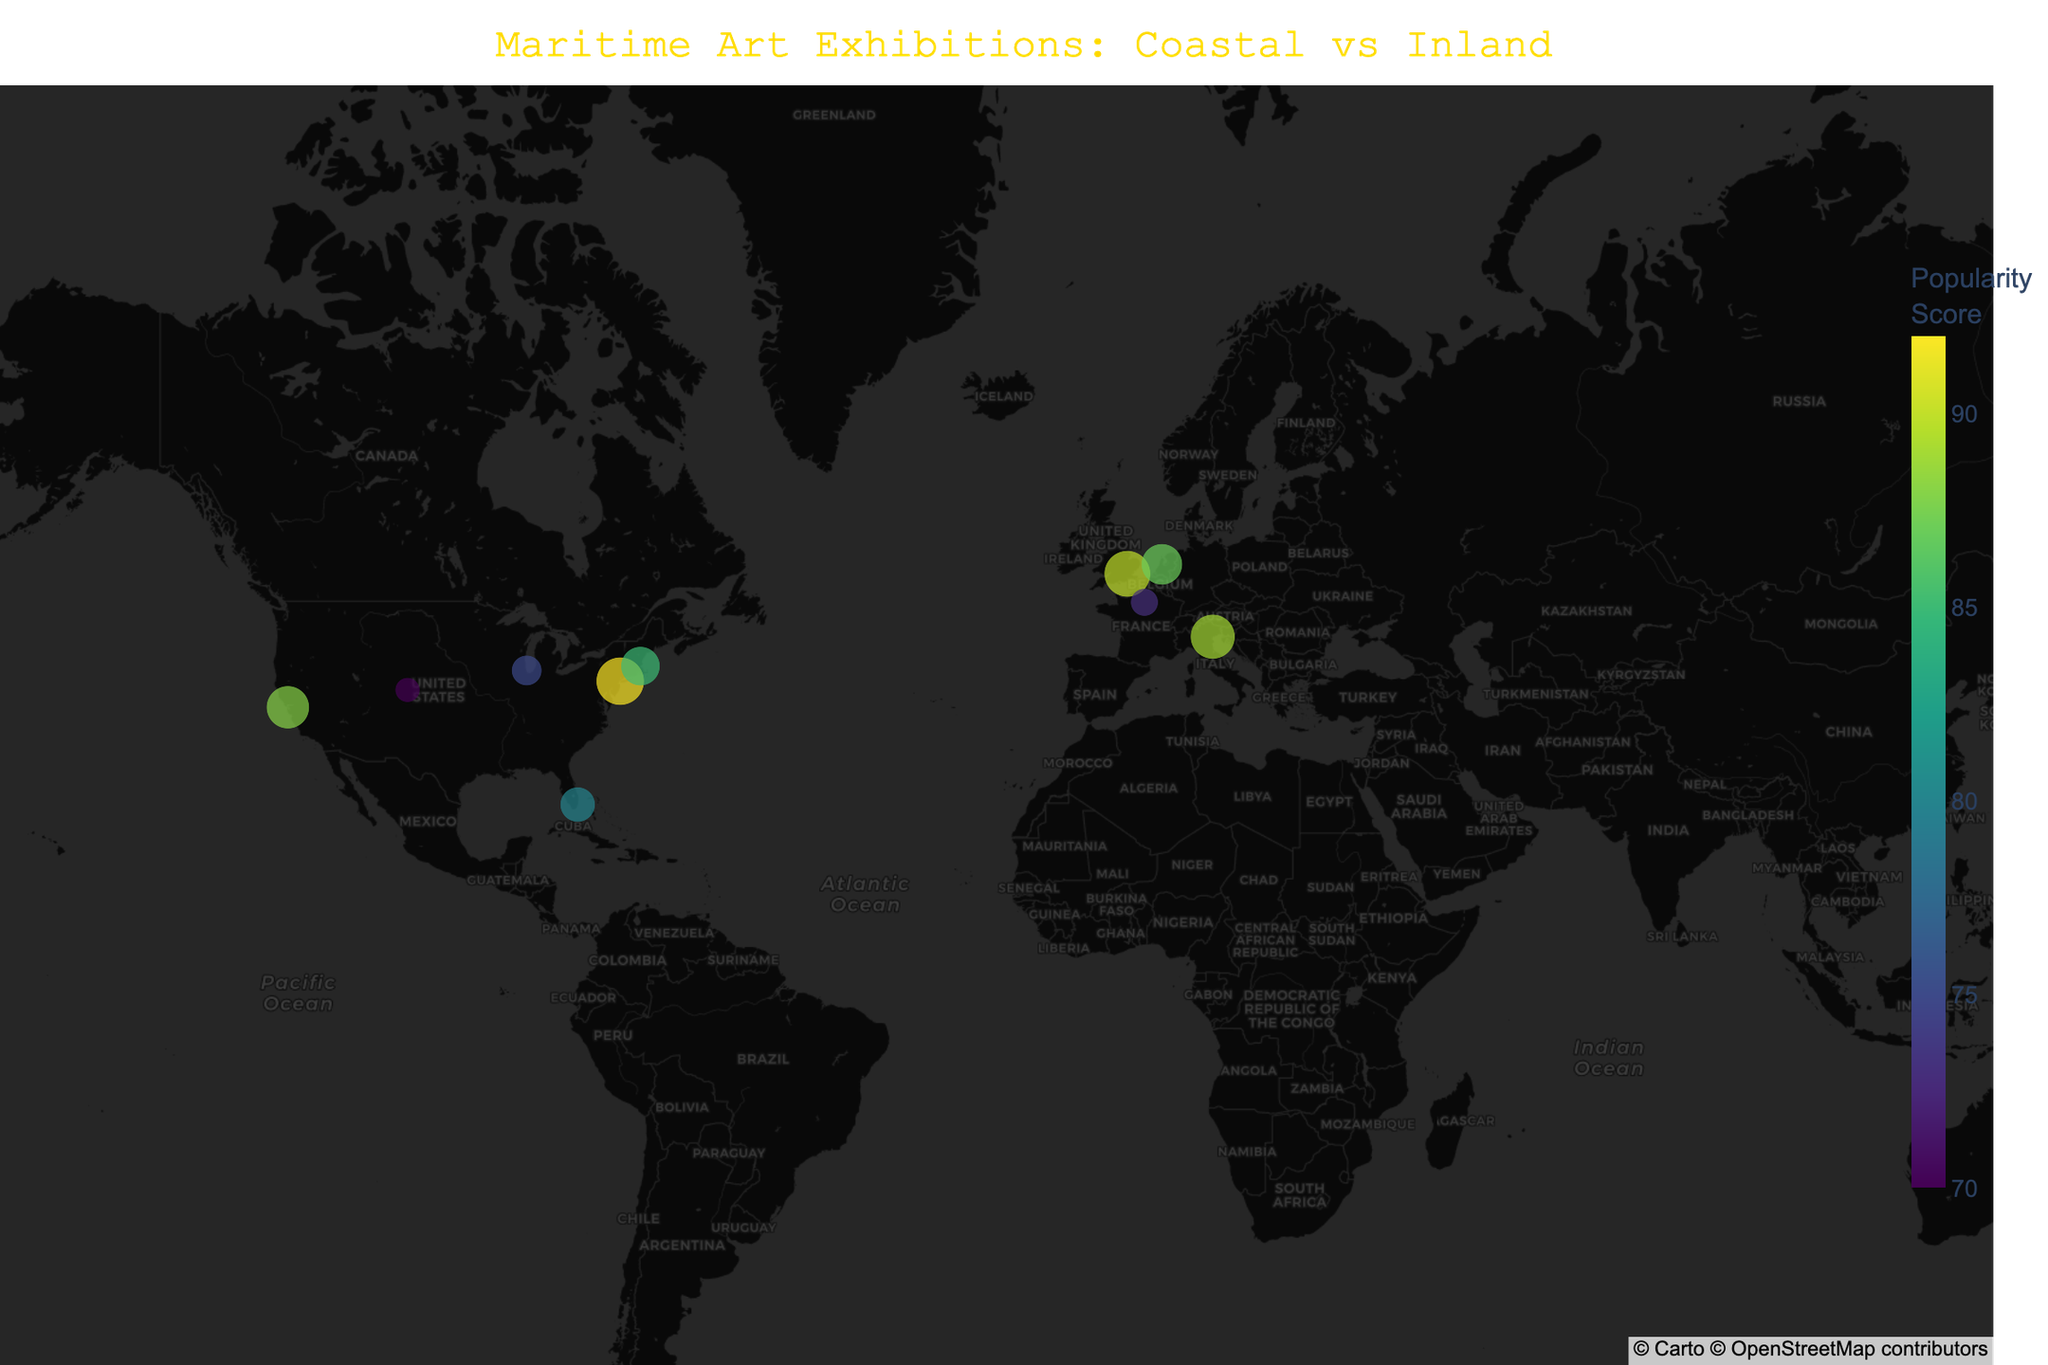How many coastal cities have exhibitions listed? To identify coastal cities, we need to consider those near water bodies like New York City, San Francisco, Boston, Miami, San Francisco, and Venice. Counting these, we get six.
Answer: 6 Which city has the highest popularity score? By examining the color gradient and the hover information in the figure, London and New York City both show high popularity scores. Checking the detailed scores, New York City has the highest at 92.
Answer: New York City Compare the total exhibition counts of coastal cities versus inland cities. Sum the "Exhibition Count" for coastal cities (NYC, SF, Boston, Miami, Venice): 15+12+10+8+13 = 58. For inland cities (Chicago, Denver, Tokyo, Paris): 6+4+7+5 = 22.
Answer: Coastal: 58, Inland: 22 What is the average popularity score for coastal cities? Sum the popularity scores for coastal cities (92+88+85+80+89) and divide by the number of cities (5). Total is 434; thus, the average is 434 / 5 = 86.8.
Answer: 86.8 Which city has the most exhibitions, and who is the top artist featured there? By identifying the maximum bubble size and checking the exhibition counts, New York City has the most exhibitions. The top artist is J.M.W. Turner.
Answer: New York City, J.M.W. Turner Compare the popularity scores of the top three cities with the most exhibitions. New York City (92), London (90), and Venice (89). Comparatively, NYC has the highest, followed by London, then Venice.
Answer: NYC>London>Venice Which inland city has the highest popularity score, and what is it? Comparing the colors and hover data for Chicago, Denver, Tokyo, and Paris, Denver has the highest popularity score of 70.
Answer: Denver, 70 What is the general trend in the number of exhibitions between coastal and inland cities? The figure shows larger bubbles (more exhibitions) predominantly in coastal cities as compared to the smaller bubbles (fewer exhibitions) predominantly in inland cities.
Answer: More exhibitions in coastal cities What color gradient represents higher popularity scores on the figure, and which city falls into this range? The color gradient used is "Viridis," where brighter colors (yellow-green) signify higher popularity scores. New York City falls into this range with the highest score of 92.
Answer: Yellow-Green, New York City What is the relationship between the exhibition count and the popularity score visually observed? Generally, cities with higher exhibition counts also display higher popularity scores, indicating a positive correlation between these two attributes.
Answer: Positive correlation 